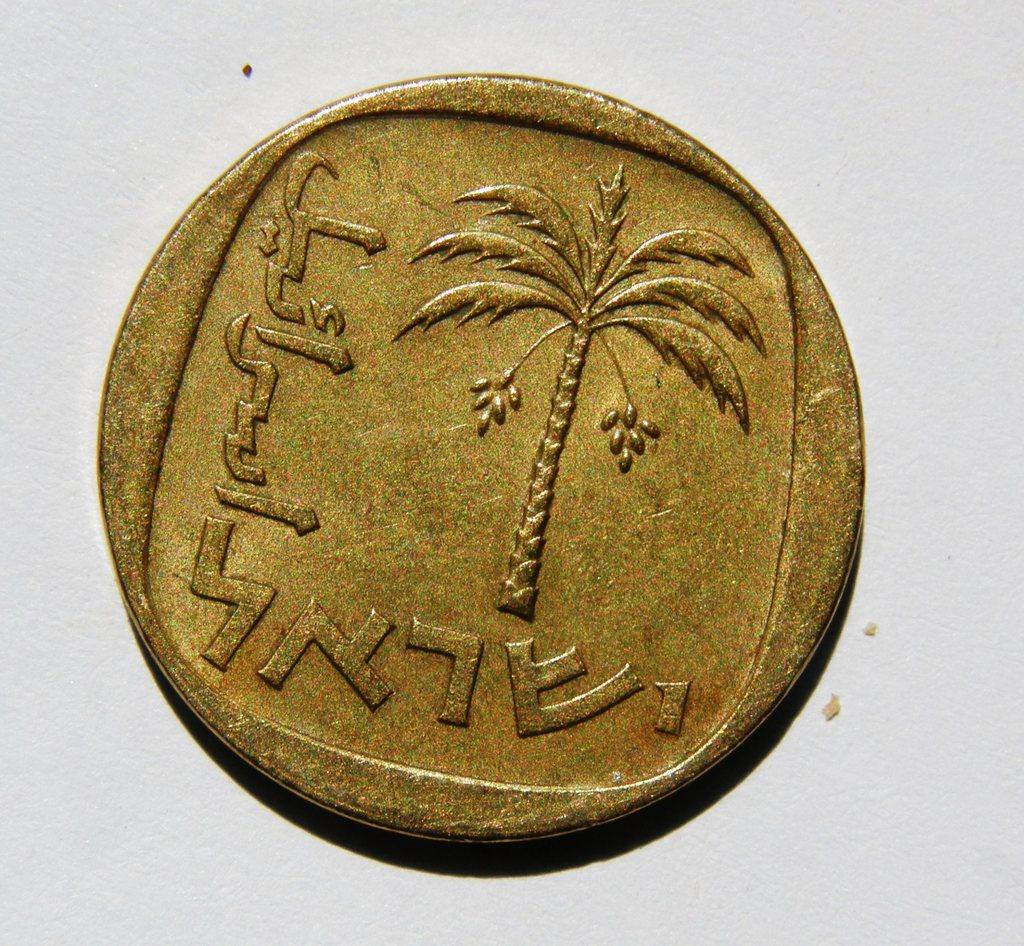<image>
Write a terse but informative summary of the picture. A gold coin shows a palm tree and a number 1 in the lower right area. 